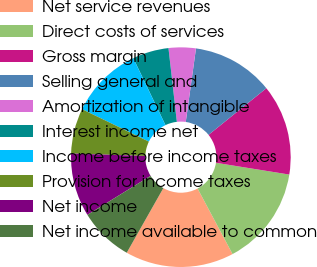<chart> <loc_0><loc_0><loc_500><loc_500><pie_chart><fcel>Net service revenues<fcel>Direct costs of services<fcel>Gross margin<fcel>Selling general and<fcel>Amortization of intangible<fcel>Interest income net<fcel>Income before income taxes<fcel>Provision for income taxes<fcel>Net income<fcel>Net income available to common<nl><fcel>16.0%<fcel>14.67%<fcel>13.33%<fcel>12.0%<fcel>4.0%<fcel>5.33%<fcel>10.67%<fcel>6.67%<fcel>9.33%<fcel>8.0%<nl></chart> 